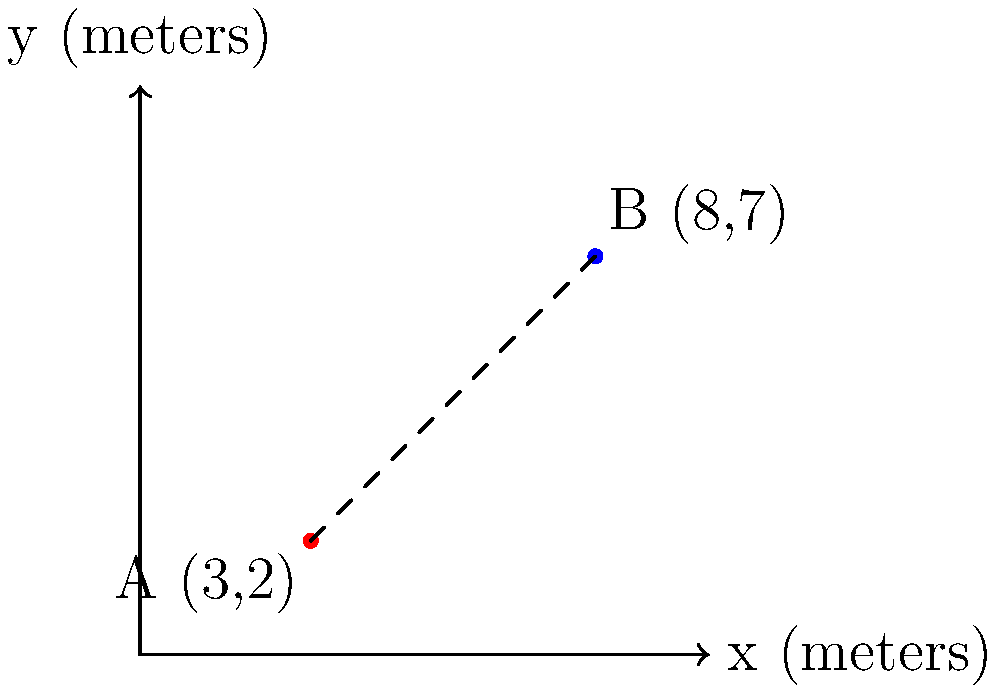As an exterior decorator planning a garden party, you need to determine the length of a string light to be hung between two trees on your landscaping plan. Tree A is located at coordinates (3,2) and Tree B is at (8,7) on your plan, where each unit represents 1 meter. What is the shortest distance between these two trees, rounded to the nearest tenth of a meter? To find the shortest distance between two points, we can use the distance formula derived from the Pythagorean theorem:

$$d = \sqrt{(x_2-x_1)^2 + (y_2-y_1)^2}$$

Where $(x_1,y_1)$ are the coordinates of the first point and $(x_2,y_2)$ are the coordinates of the second point.

Let's solve this step-by-step:

1) Identify the coordinates:
   Point A: $(x_1,y_1) = (3,2)$
   Point B: $(x_2,y_2) = (8,7)$

2) Plug these values into the distance formula:
   $$d = \sqrt{(8-3)^2 + (7-2)^2}$$

3) Simplify inside the parentheses:
   $$d = \sqrt{5^2 + 5^2}$$

4) Calculate the squares:
   $$d = \sqrt{25 + 25}$$

5) Add under the square root:
   $$d = \sqrt{50}$$

6) Simplify the square root:
   $$d = 5\sqrt{2} \approx 7.071$$

7) Round to the nearest tenth:
   $$d \approx 7.1$$

Therefore, the shortest distance between the two trees is approximately 7.1 meters.
Answer: 7.1 meters 